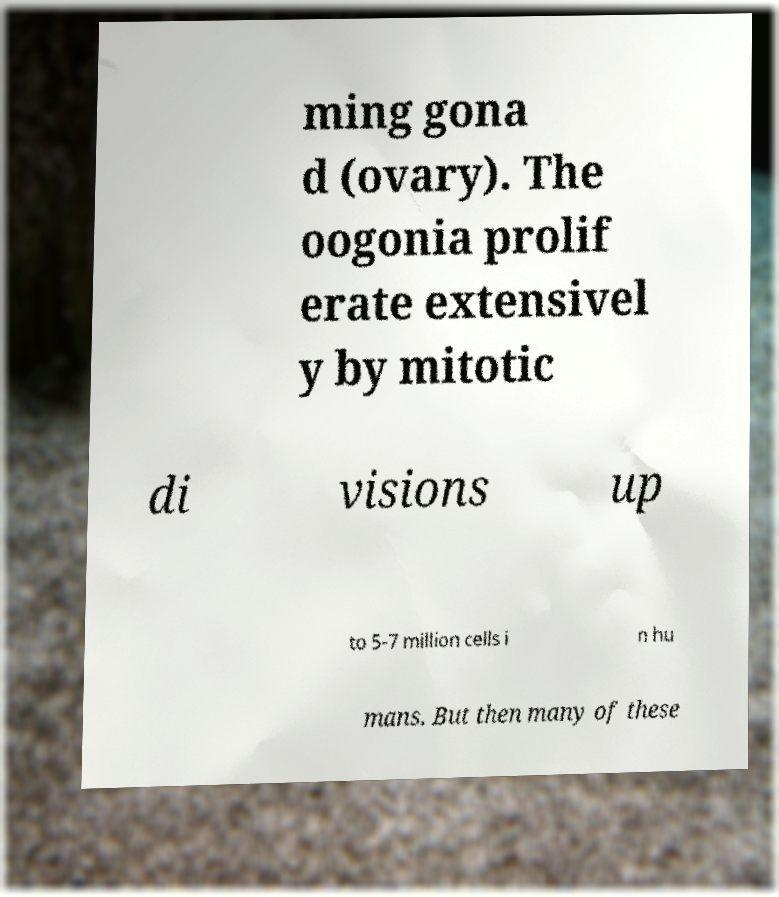For documentation purposes, I need the text within this image transcribed. Could you provide that? ming gona d (ovary). The oogonia prolif erate extensivel y by mitotic di visions up to 5-7 million cells i n hu mans. But then many of these 